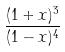<formula> <loc_0><loc_0><loc_500><loc_500>\frac { ( 1 + x ) ^ { 3 } } { ( 1 - x ) ^ { 4 } }</formula> 